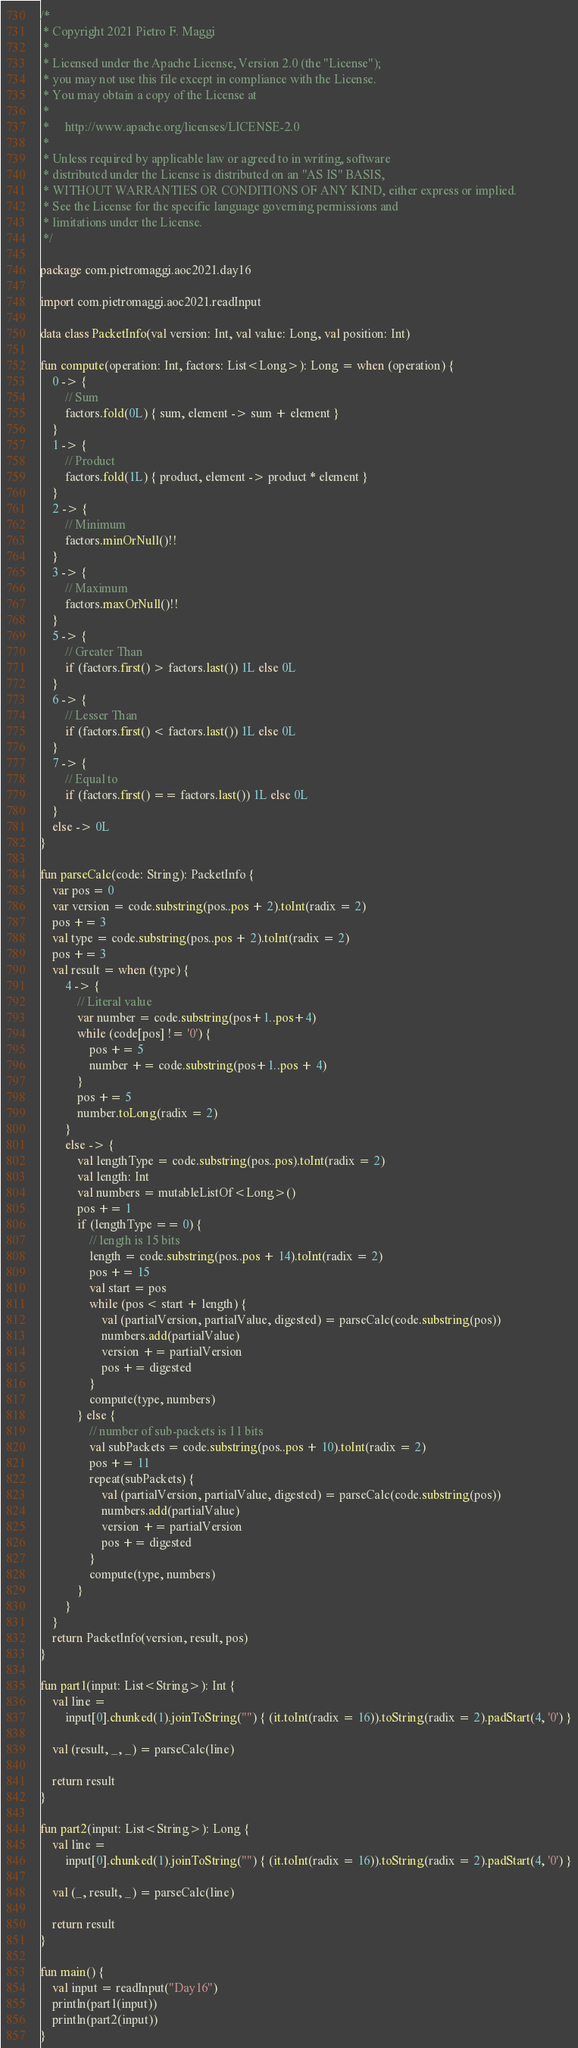<code> <loc_0><loc_0><loc_500><loc_500><_Kotlin_>/*
 * Copyright 2021 Pietro F. Maggi
 *
 * Licensed under the Apache License, Version 2.0 (the "License");
 * you may not use this file except in compliance with the License.
 * You may obtain a copy of the License at
 *
 *     http://www.apache.org/licenses/LICENSE-2.0
 *
 * Unless required by applicable law or agreed to in writing, software
 * distributed under the License is distributed on an "AS IS" BASIS,
 * WITHOUT WARRANTIES OR CONDITIONS OF ANY KIND, either express or implied.
 * See the License for the specific language governing permissions and
 * limitations under the License.
 */

package com.pietromaggi.aoc2021.day16

import com.pietromaggi.aoc2021.readInput

data class PacketInfo(val version: Int, val value: Long, val position: Int)

fun compute(operation: Int, factors: List<Long>): Long = when (operation) {
    0 -> {
        // Sum
        factors.fold(0L) { sum, element -> sum + element }
    }
    1 -> {
        // Product
        factors.fold(1L) { product, element -> product * element }
    }
    2 -> {
        // Minimum
        factors.minOrNull()!!
    }
    3 -> {
        // Maximum
        factors.maxOrNull()!!
    }
    5 -> {
        // Greater Than
        if (factors.first() > factors.last()) 1L else 0L
    }
    6 -> {
        // Lesser Than
        if (factors.first() < factors.last()) 1L else 0L
    }
    7 -> {
        // Equal to
        if (factors.first() == factors.last()) 1L else 0L
    }
    else -> 0L
}

fun parseCalc(code: String): PacketInfo {
    var pos = 0
    var version = code.substring(pos..pos + 2).toInt(radix = 2)
    pos += 3
    val type = code.substring(pos..pos + 2).toInt(radix = 2)
    pos += 3
    val result = when (type) {
        4 -> {
            // Literal value
            var number = code.substring(pos+1..pos+4)
            while (code[pos] != '0') {
                pos += 5
                number += code.substring(pos+1..pos + 4)
            }
            pos += 5
            number.toLong(radix = 2)
        }
        else -> {
            val lengthType = code.substring(pos..pos).toInt(radix = 2)
            val length: Int
            val numbers = mutableListOf<Long>()
            pos += 1
            if (lengthType == 0) {
                // length is 15 bits
                length = code.substring(pos..pos + 14).toInt(radix = 2)
                pos += 15
                val start = pos
                while (pos < start + length) {
                    val (partialVersion, partialValue, digested) = parseCalc(code.substring(pos))
                    numbers.add(partialValue)
                    version += partialVersion
                    pos += digested
                }
                compute(type, numbers)
            } else {
                // number of sub-packets is 11 bits
                val subPackets = code.substring(pos..pos + 10).toInt(radix = 2)
                pos += 11
                repeat(subPackets) {
                    val (partialVersion, partialValue, digested) = parseCalc(code.substring(pos))
                    numbers.add(partialValue)
                    version += partialVersion
                    pos += digested
                }
                compute(type, numbers)
            }
        }
    }
    return PacketInfo(version, result, pos)
}

fun part1(input: List<String>): Int {
    val line =
        input[0].chunked(1).joinToString("") { (it.toInt(radix = 16)).toString(radix = 2).padStart(4, '0') }

    val (result, _, _) = parseCalc(line)

    return result
}

fun part2(input: List<String>): Long {
    val line =
        input[0].chunked(1).joinToString("") { (it.toInt(radix = 16)).toString(radix = 2).padStart(4, '0') }

    val (_, result, _) = parseCalc(line)

    return result
}

fun main() {
    val input = readInput("Day16")
    println(part1(input))
    println(part2(input))
}
</code> 